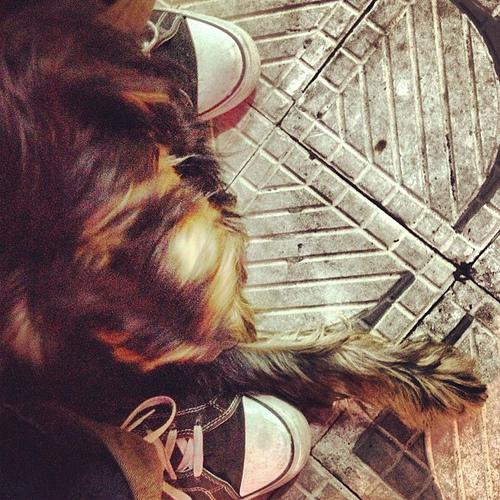Question: what is between the shoes?
Choices:
A. Flowers.
B. Leaves.
C. Animal.
D. Rocks.
Answer with the letter. Answer: C Question: where are the shoes?
Choices:
A. On his feet.
B. By the bed.
C. In the box.
D. On ground.
Answer with the letter. Answer: D Question: what is the ground made of?
Choices:
A. Tiles.
B. Dirt.
C. Concrete.
D. Gravel.
Answer with the letter. Answer: A Question: what color are the toes of the shoes?
Choices:
A. White.
B. Gray.
C. Blue.
D. Yellow.
Answer with the letter. Answer: A Question: what kind of pants is the person wearing the shoes wearing?
Choices:
A. Sweats.
B. Slacks.
C. Plaid.
D. Jeans.
Answer with the letter. Answer: D Question: what color are the tiles?
Choices:
A. Blue.
B. Orange.
C. Gray.
D. Yellow.
Answer with the letter. Answer: C 